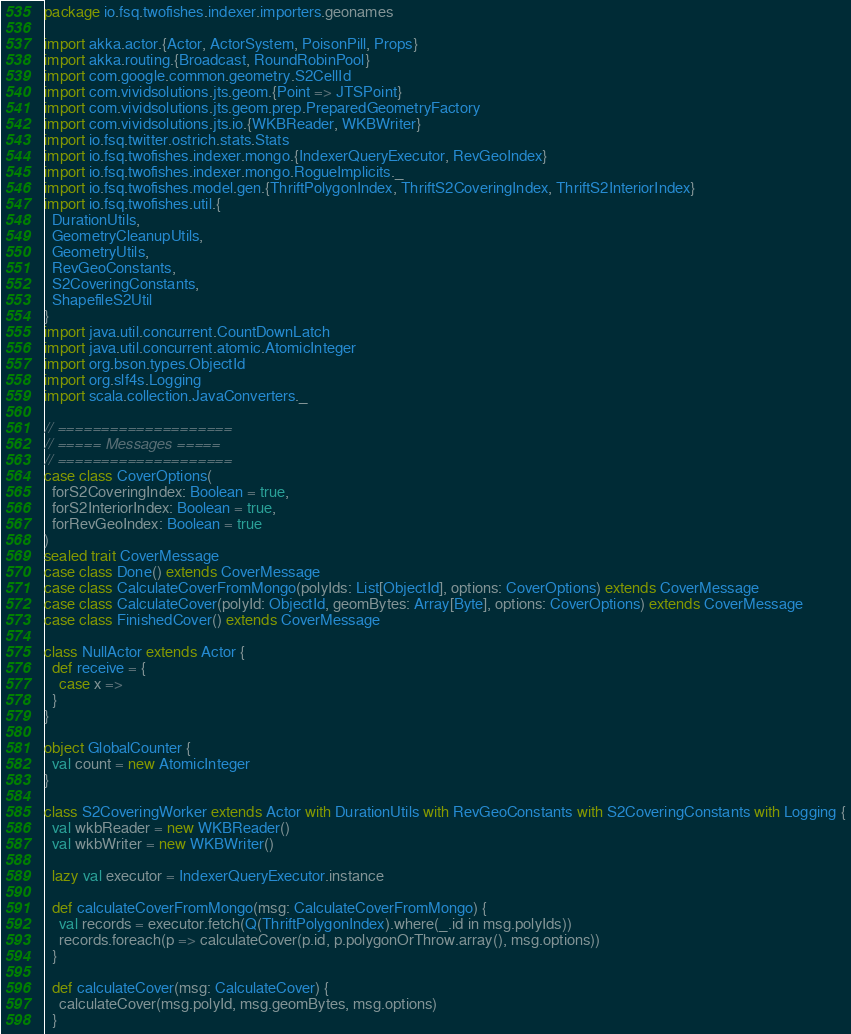Convert code to text. <code><loc_0><loc_0><loc_500><loc_500><_Scala_>package io.fsq.twofishes.indexer.importers.geonames

import akka.actor.{Actor, ActorSystem, PoisonPill, Props}
import akka.routing.{Broadcast, RoundRobinPool}
import com.google.common.geometry.S2CellId
import com.vividsolutions.jts.geom.{Point => JTSPoint}
import com.vividsolutions.jts.geom.prep.PreparedGeometryFactory
import com.vividsolutions.jts.io.{WKBReader, WKBWriter}
import io.fsq.twitter.ostrich.stats.Stats
import io.fsq.twofishes.indexer.mongo.{IndexerQueryExecutor, RevGeoIndex}
import io.fsq.twofishes.indexer.mongo.RogueImplicits._
import io.fsq.twofishes.model.gen.{ThriftPolygonIndex, ThriftS2CoveringIndex, ThriftS2InteriorIndex}
import io.fsq.twofishes.util.{
  DurationUtils,
  GeometryCleanupUtils,
  GeometryUtils,
  RevGeoConstants,
  S2CoveringConstants,
  ShapefileS2Util
}
import java.util.concurrent.CountDownLatch
import java.util.concurrent.atomic.AtomicInteger
import org.bson.types.ObjectId
import org.slf4s.Logging
import scala.collection.JavaConverters._

// ====================
// ===== Messages =====
// ====================
case class CoverOptions(
  forS2CoveringIndex: Boolean = true,
  forS2InteriorIndex: Boolean = true,
  forRevGeoIndex: Boolean = true
)
sealed trait CoverMessage
case class Done() extends CoverMessage
case class CalculateCoverFromMongo(polyIds: List[ObjectId], options: CoverOptions) extends CoverMessage
case class CalculateCover(polyId: ObjectId, geomBytes: Array[Byte], options: CoverOptions) extends CoverMessage
case class FinishedCover() extends CoverMessage

class NullActor extends Actor {
  def receive = {
    case x =>
  }
}

object GlobalCounter {
  val count = new AtomicInteger
}

class S2CoveringWorker extends Actor with DurationUtils with RevGeoConstants with S2CoveringConstants with Logging {
  val wkbReader = new WKBReader()
  val wkbWriter = new WKBWriter()

  lazy val executor = IndexerQueryExecutor.instance

  def calculateCoverFromMongo(msg: CalculateCoverFromMongo) {
    val records = executor.fetch(Q(ThriftPolygonIndex).where(_.id in msg.polyIds))
    records.foreach(p => calculateCover(p.id, p.polygonOrThrow.array(), msg.options))
  }

  def calculateCover(msg: CalculateCover) {
    calculateCover(msg.polyId, msg.geomBytes, msg.options)
  }
</code> 